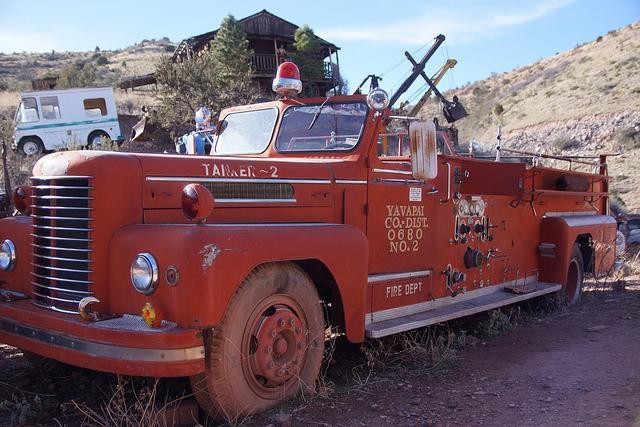What sort of emergency is the truck seen here prepared to immediately handle?
Indicate the correct response by choosing from the four available options to answer the question.
Options: Break ins, none, heart attack, towing. None. 